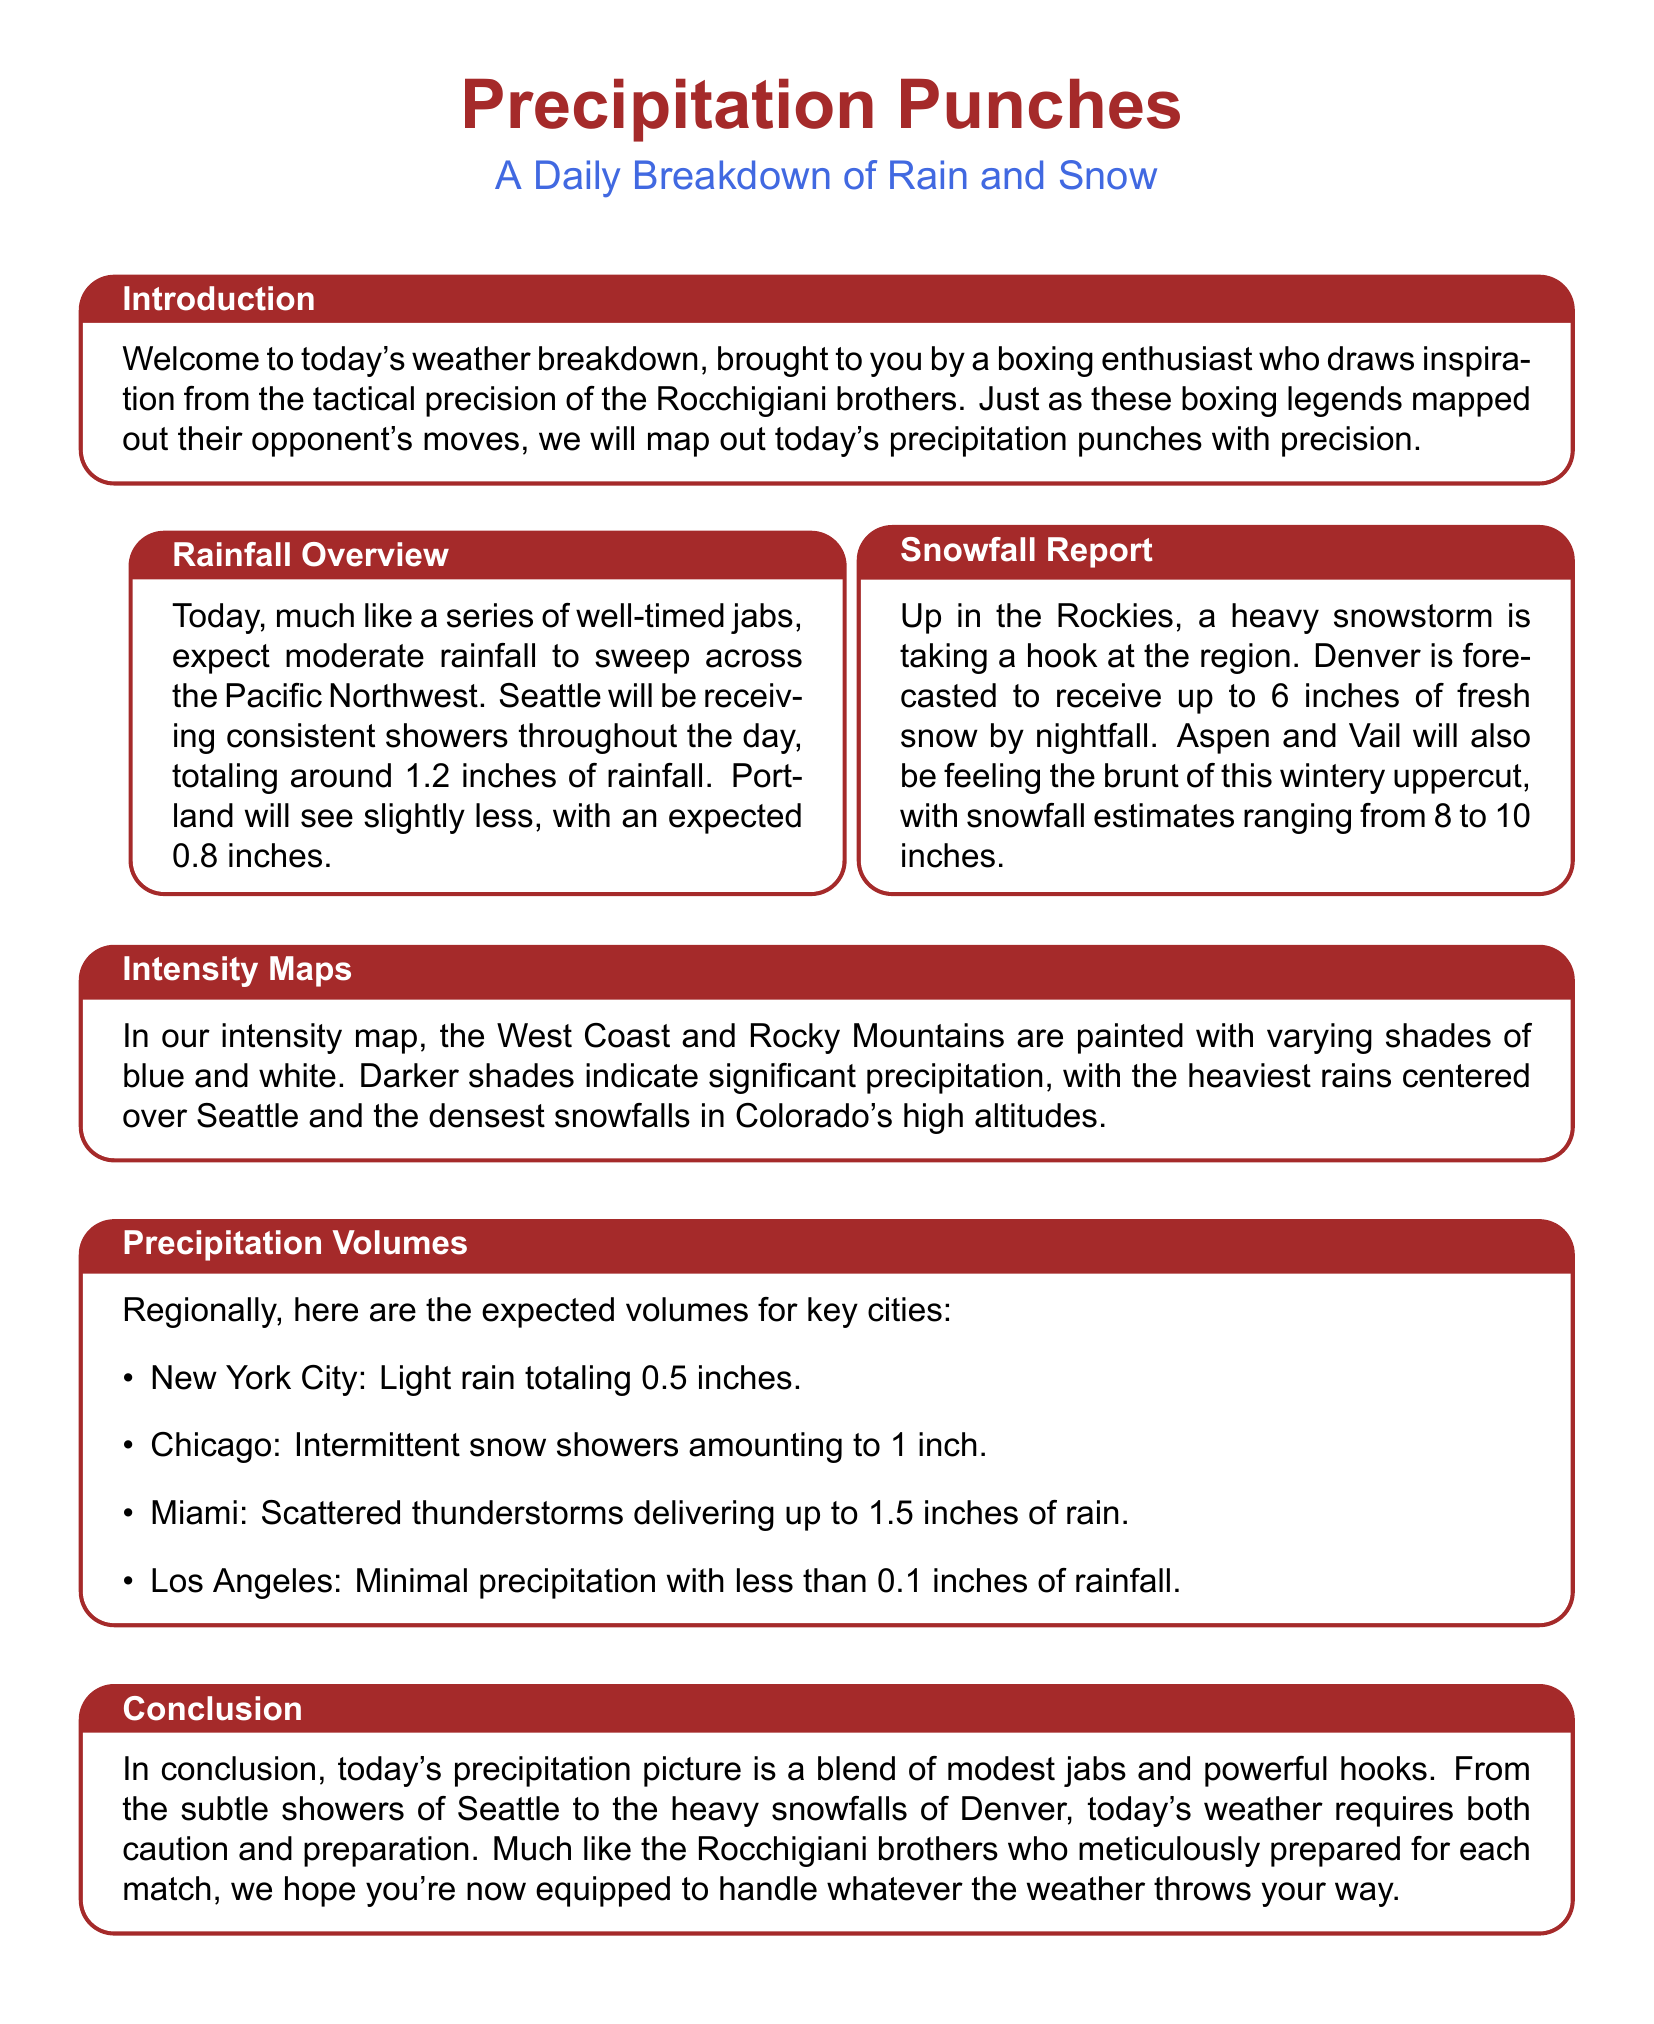What is the total expected rainfall in Seattle? The document states that Seattle will be receiving consistent showers throughout the day, totaling around 1.2 inches of rainfall.
Answer: 1.2 inches What is the precipitation forecast for Denver? The snowfall report mentions that Denver is forecasted to receive up to 6 inches of fresh snow by nightfall.
Answer: 6 inches How much rainfall is expected in Miami? The precipitation volumes section indicates that scattered thunderstorms in Miami will deliver up to 1.5 inches of rain.
Answer: 1.5 inches What type of precipitation is expected in Los Angeles? The document notes that Los Angeles will have minimal precipitation with less than 0.1 inches of rainfall.
Answer: Minimal precipitation What does the intensity map indicate about the precipitation? The intensity maps description explains that darker shades indicate significant precipitation, with the heaviest rains centered over Seattle.
Answer: Significant precipitation Which cities will experience heavy snow? The snowfall report specifies that Aspen and Vail will have snowfall estimates ranging from 8 to 10 inches.
Answer: Aspen and Vail In which region is moderate rainfall expected today? The rainfall overview states that moderate rainfall is expected across the Pacific Northwest, including Seattle and Portland.
Answer: Pacific Northwest How does today's weather relate to the Rocchigiani brothers? The introduction compares the mapping of precipitation to the tactical precision of the Rocchigiani brothers in boxing.
Answer: Tactical precision 